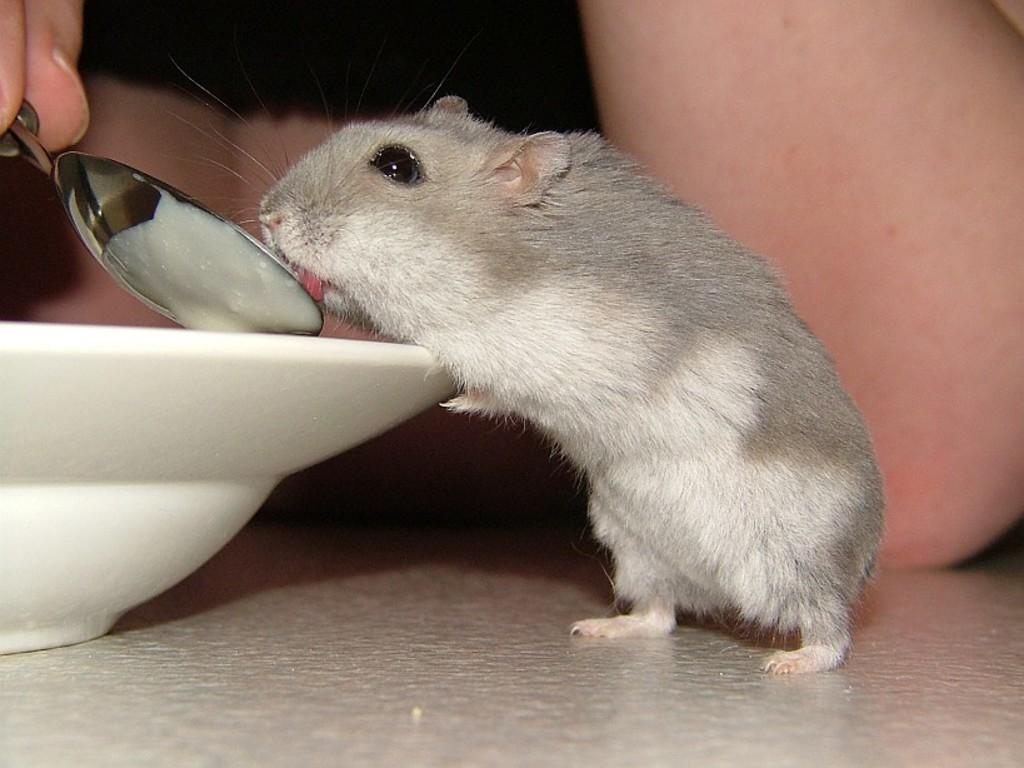What animal is present in the image? There is a rat in the image. What type of bowl is in the image? There is a white color bowl in the image. Where is the bowl located? The bowl is on a surface. Can you describe any human presence in the image? There is a person's hand holding a spoon in the background of the image. What type of reward does the daughter receive for catching the rat in the image? There is no daughter present in the image, and no reward is mentioned or depicted. 